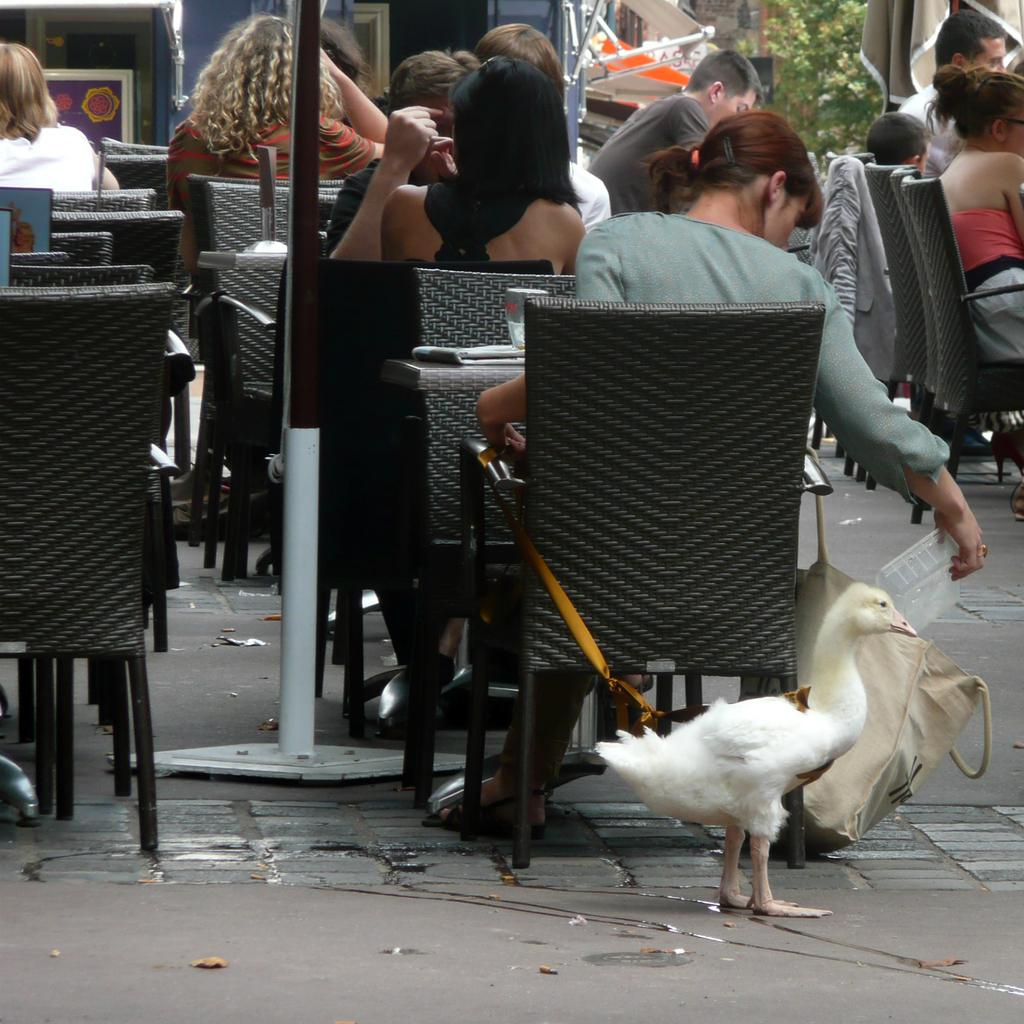What type of animal can be seen in the image? There is a bird in the image. What are the people in the image doing? The people in the image are sitting on chairs. What object is present in the image that is typically used for support or guidance? There is a pole in the image. What type of plant is visible in the image? There is a tree in the image. How many geese are resting on the bed in the image? There is no bed or geese present in the image. What type of stick is being used by the bird in the image? There is no stick being used by the bird in the image. 